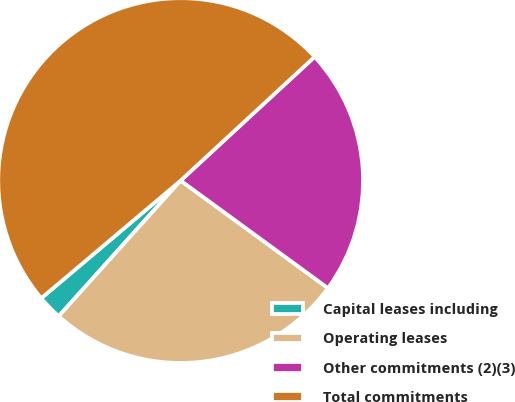Convert chart to OTSL. <chart><loc_0><loc_0><loc_500><loc_500><pie_chart><fcel>Capital leases including<fcel>Operating leases<fcel>Other commitments (2)(3)<fcel>Total commitments<nl><fcel>2.19%<fcel>26.62%<fcel>21.91%<fcel>49.29%<nl></chart> 